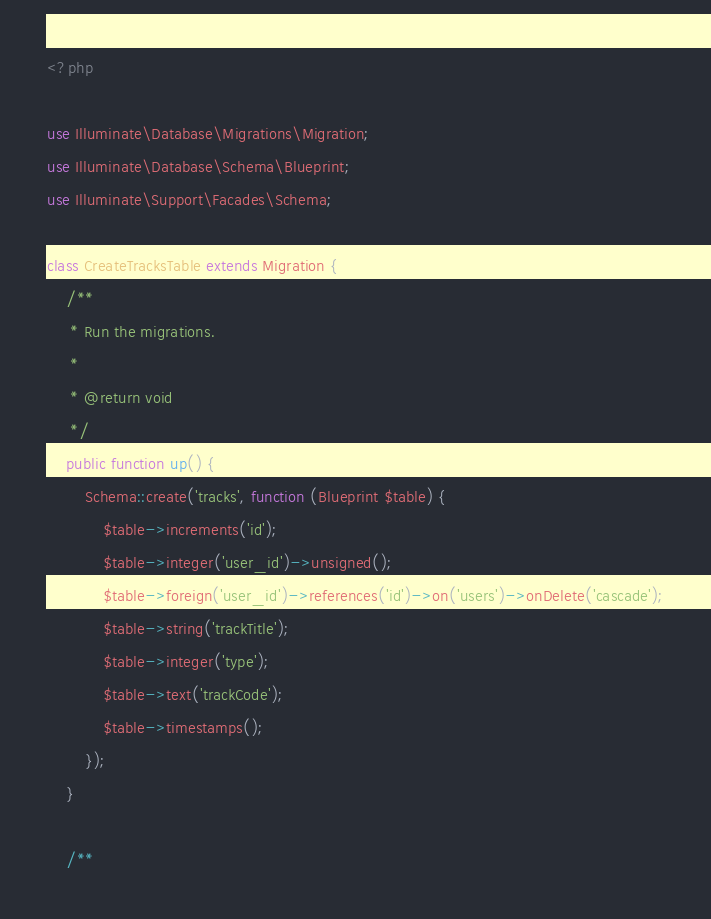Convert code to text. <code><loc_0><loc_0><loc_500><loc_500><_PHP_><?php

use Illuminate\Database\Migrations\Migration;
use Illuminate\Database\Schema\Blueprint;
use Illuminate\Support\Facades\Schema;

class CreateTracksTable extends Migration {
	/**
	 * Run the migrations.
	 *
	 * @return void
	 */
	public function up() {
		Schema::create('tracks', function (Blueprint $table) {
			$table->increments('id');
			$table->integer('user_id')->unsigned();
			$table->foreign('user_id')->references('id')->on('users')->onDelete('cascade');
			$table->string('trackTitle');
			$table->integer('type');
			$table->text('trackCode');
			$table->timestamps();
		});
	}

	/**</code> 